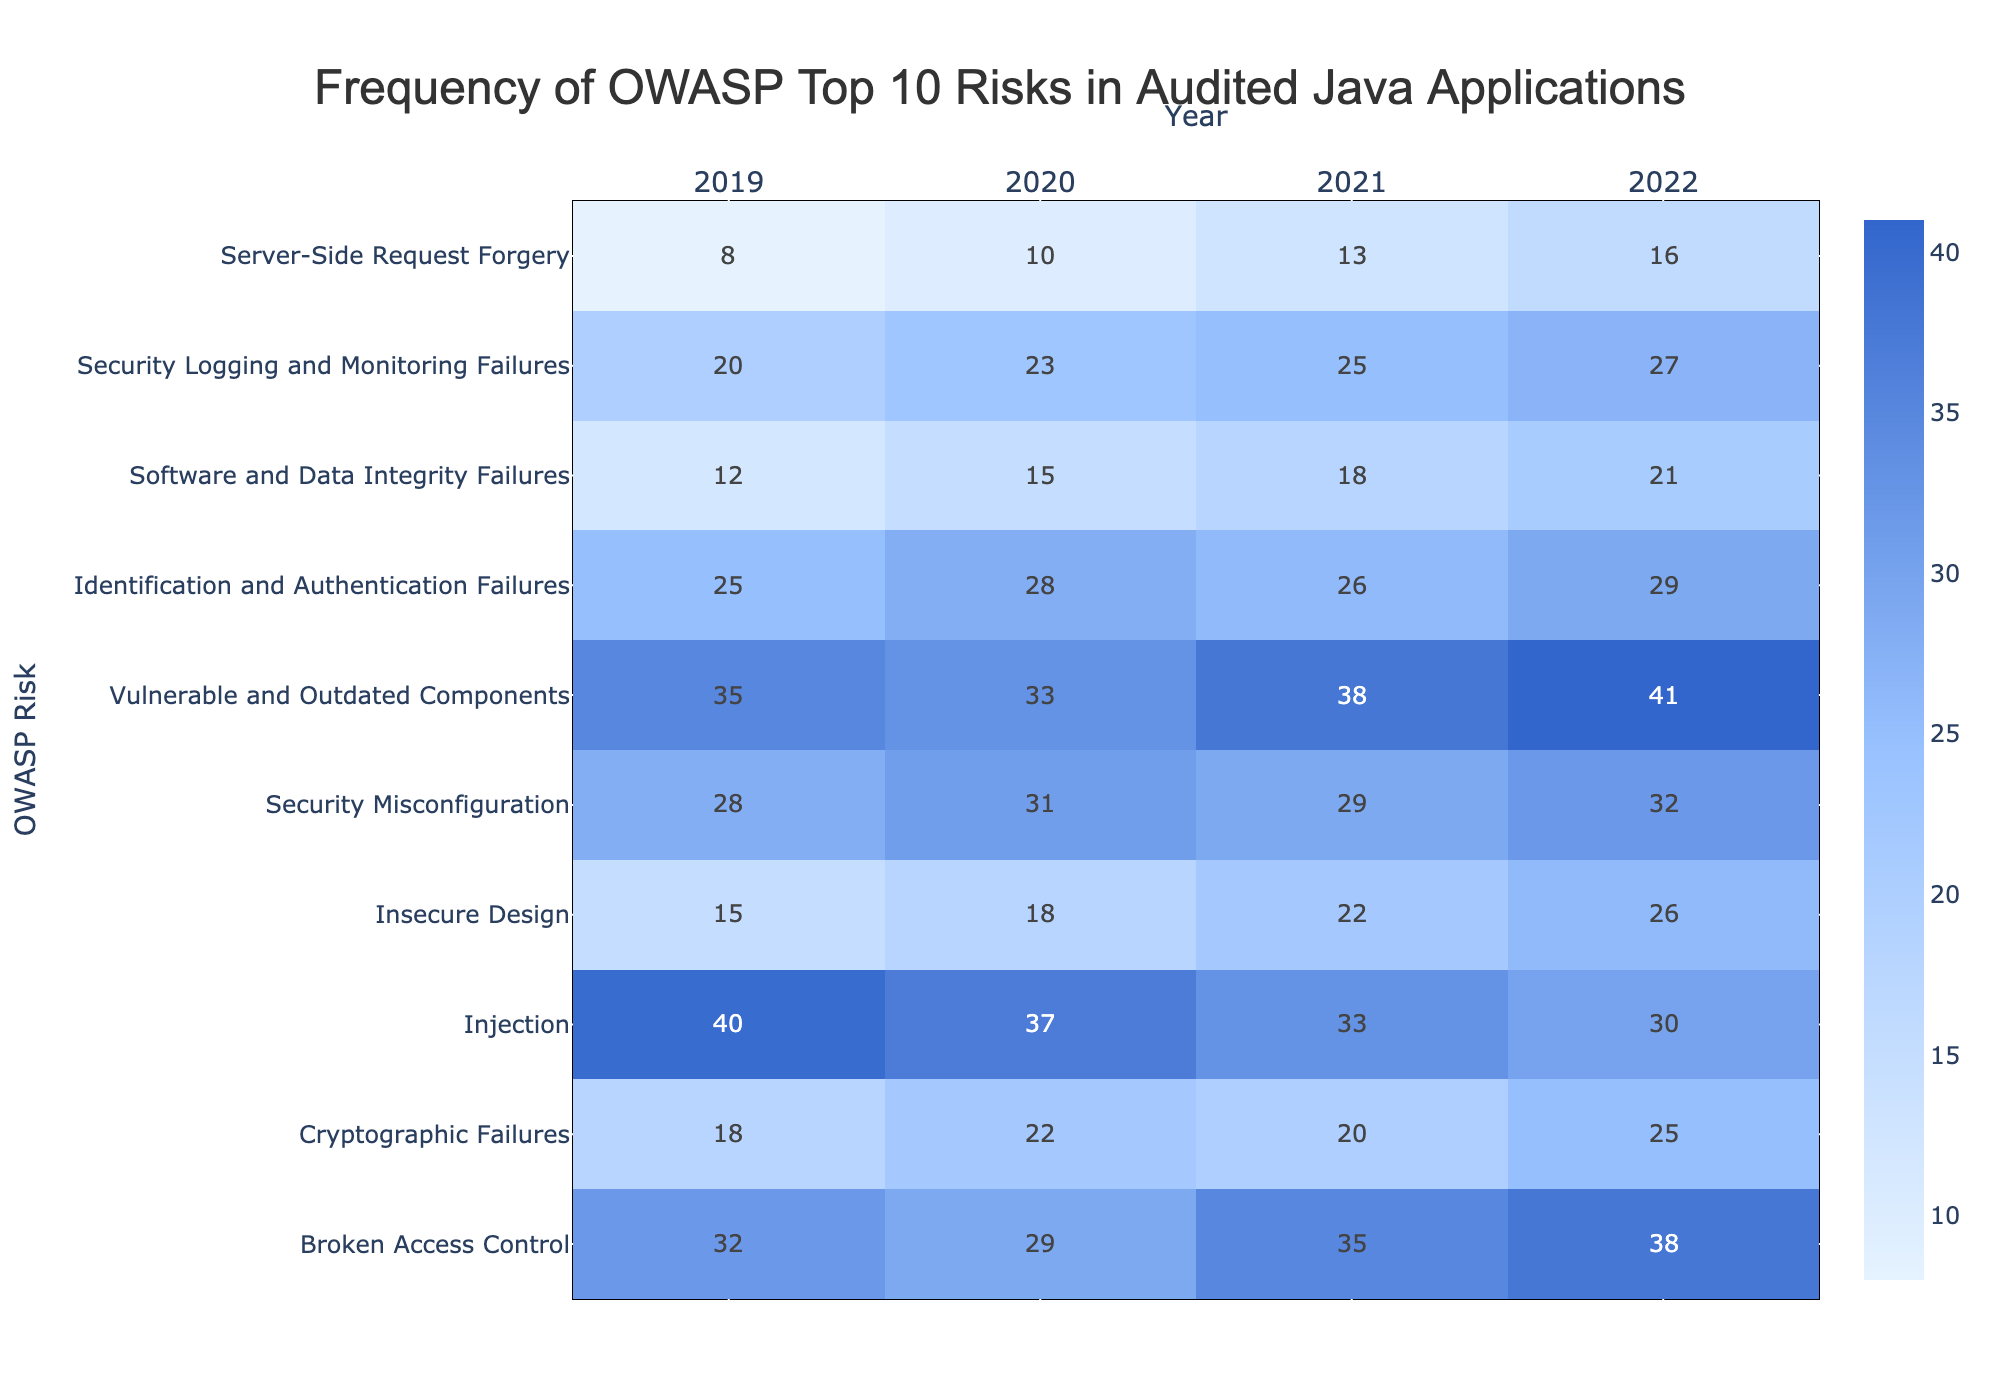What was the highest frequency of any OWASP risk in 2022? Looking at the 2022 column, the highest value is 41, which corresponds to "Vulnerable and Outdated Components."
Answer: 41 Which year saw the highest increase in "Injection" risk frequency compared to the previous year? The frequencies for "Injection" are 40 in 2019, 37 in 2020, 33 in 2021, and 30 in 2022. The highest increase occurred from 2019 to 2020, when it dropped by 3.
Answer: From 2019 to 2020 What is the total frequency of "Security Misconfiguration" risks over the four years? The frequencies are 28 in 2019, 31 in 2020, 29 in 2021, and 32 in 2022. Adding these numbers gives a total of 28 + 31 + 29 + 32 = 120.
Answer: 120 Was there a decrease in "Cryptographic Failures" risk frequency from 2020 to 2021? The value for "Cryptographic Failures" is 22 in 2020 and 20 in 2021, indicating a decrease.
Answer: Yes What is the average frequency of "Identification and Authentication Failures" over the years? The frequencies for the years are 25, 28, 26, and 29. The sum is 25 + 28 + 26 + 29 = 108, and there are 4 years, so the average is 108 / 4 = 27.
Answer: 27 Which two risks had the same frequency in 2021, and what was that frequency? In 2021, "Injection" had a frequency of 33, and "Vulnerable and Outdated Components" had a frequency of 38. No risks had the same frequency.
Answer: None What is the difference in frequency for "Server-Side Request Forgery" between 2019 and 2022? The frequency in 2019 is 8, and in 2022 it is 16. The difference is 16 - 8 = 8.
Answer: 8 Which OWASP risk showed the most consistent frequency over the years? By examining the values, "Injection" shows a decrease from 40 to 30 with no fluctuations, while "Software and Data Integrity Failures" increased consistently each year. So, "Software and Data Integrity Failures" is more consistent.
Answer: "Software and Data Integrity Failures" What was the median frequency of all risks in 2020? The sorted frequencies for 2020 are: 10, 22, 23, 25, 28, 29, 31, 33, 37, 41. The median is the average of the 5th and 6th values, which are 28 and 29. Thus, (28 + 29) / 2 = 28.5.
Answer: 28.5 In which year did "Broken Access Control" have its highest frequency? The frequencies are 32 in 2019, 29 in 2020, 35 in 2021, and 38 in 2022. The highest frequency occurred in 2022 with 38.
Answer: 2022 